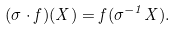Convert formula to latex. <formula><loc_0><loc_0><loc_500><loc_500>( \sigma \cdot f ) ( X ) = f ( \sigma ^ { - 1 } X ) .</formula> 